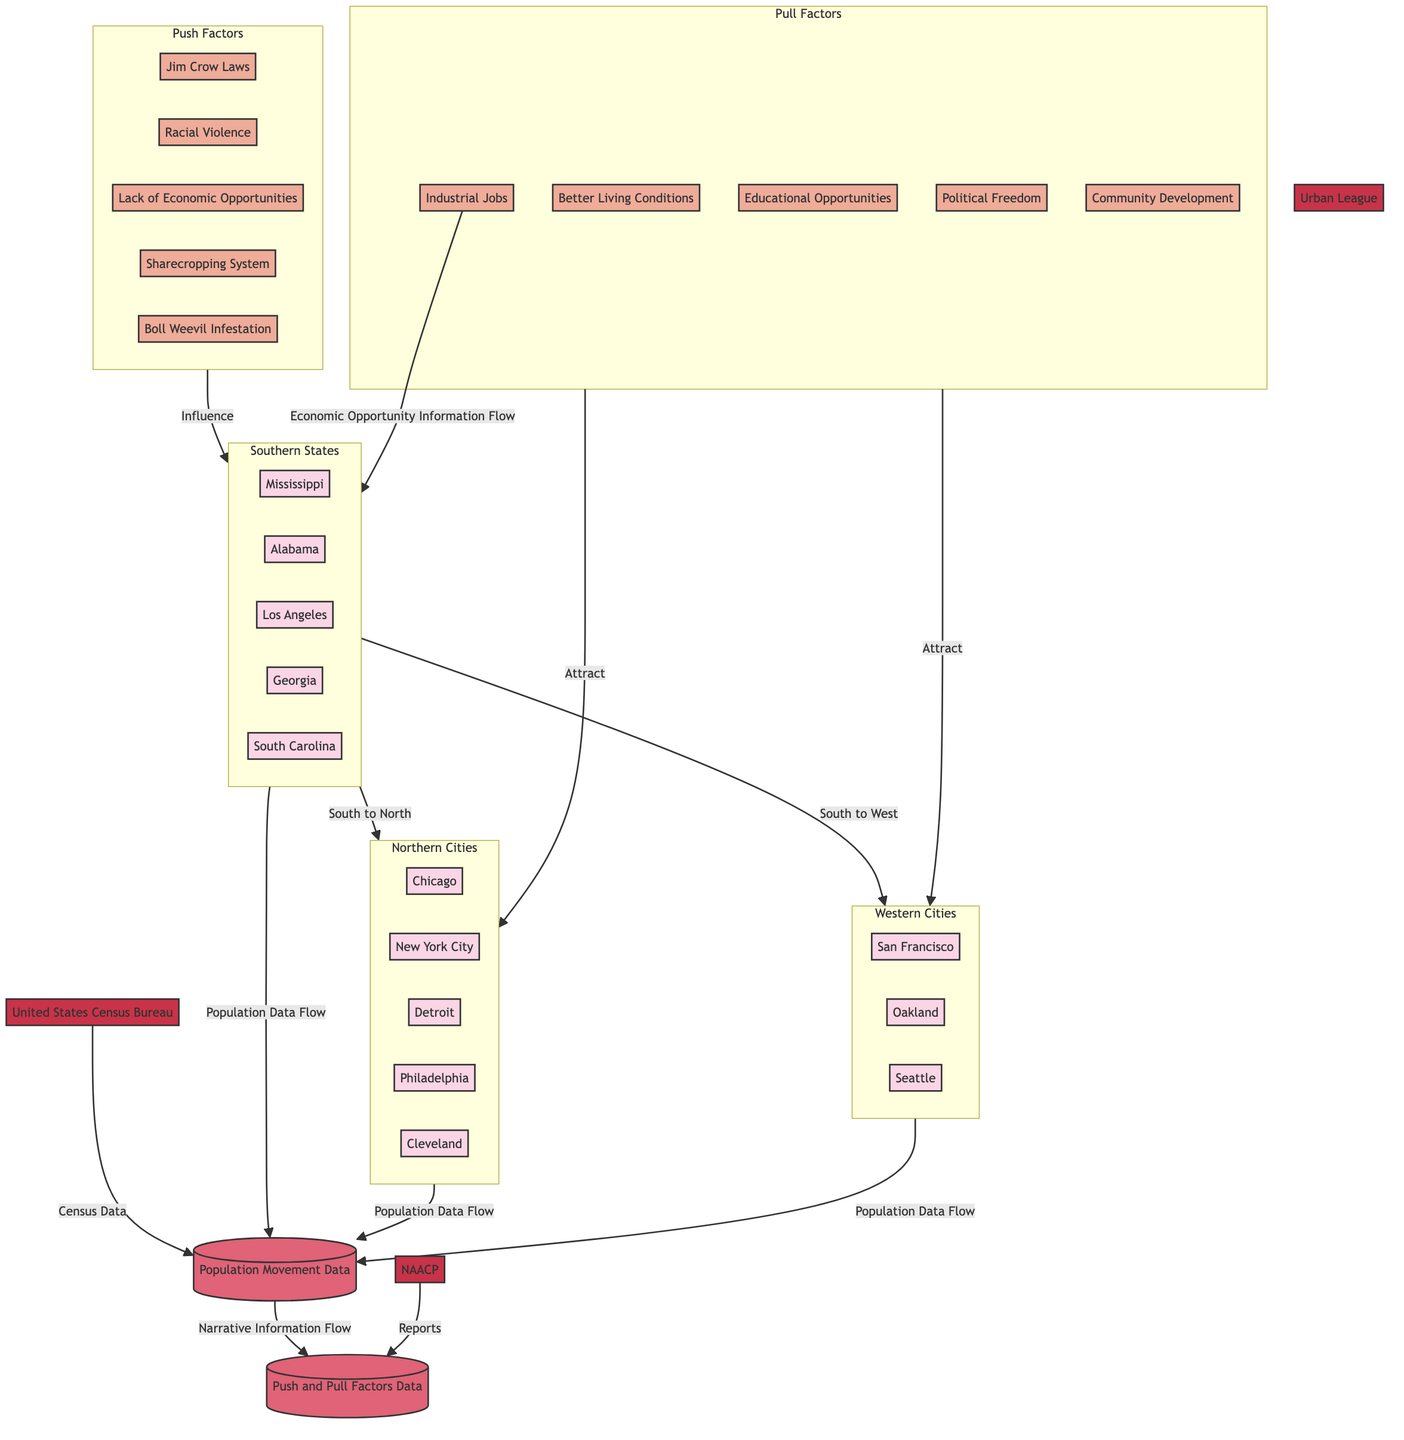What are the major destination cities for migrants? The major destination cities are Chicago, New York City, Detroit, Philadelphia, Cleveland, Los Angeles, San Francisco, Oakland, and Seattle. These cities are visible in the Northern Cities and Western Cities subgraphs.
Answer: Chicago, New York City, Detroit, Philadelphia, Cleveland, Los Angeles, San Francisco, Oakland, Seattle How many push factors are listed in the diagram? There are five push factors present in the Push Factors subgraph: Jim Crow Laws, Racial Violence, Lack of Economic Opportunities, Sharecropping System, and Boll Weevil Infestation. Counting these factors gives us a total of five.
Answer: 5 Which Southern State is connected to both Northern Cities and Western Cities? The Southern States subgraph shows that all listed states connect to both Northern and Western Cities. This means that any state, such as Mississippi, connects to both.
Answer: Mississippi What influences migration from Southern States? The migration from Southern States is influenced by various push factors including, Jim Crow Laws, Racial Violence, Lack of Economic Opportunities, Sharecropping System, and Boll Weevil Infestation, as indicated in the Push Factors subgraph.
Answer: Push Factors Which external entity provides census data? The United States Census Bureau is the external entity that provides census data to the Population Movement Data store, as depicted in the flow connecting these two nodes.
Answer: United States Census Bureau What type of information flows from Pull Factors to Northern Cities? The flow from Pull Factors to Northern Cities indicates that pull factors attract individuals to these cities, specifically highlighting the Economic Opportunity Information Flow mentioned in the context of job availability.
Answer: Attract How many data stores are present in the diagram? There are two data stores in the diagram: Population Movement Data and Push and Pull Factors Data. The data stores hold records relevant to migration patterns and factors influencing migration. Counting these stores yields a total of two.
Answer: 2 What type of factors are represented in both Pull Factors and Push Factors? Both Pull Factors and Push Factors are represented by Economic Opportunities, as push factors indicate a lack while pull factors highlight available jobs, creating contrast around this concept.
Answer: Economic Opportunities 